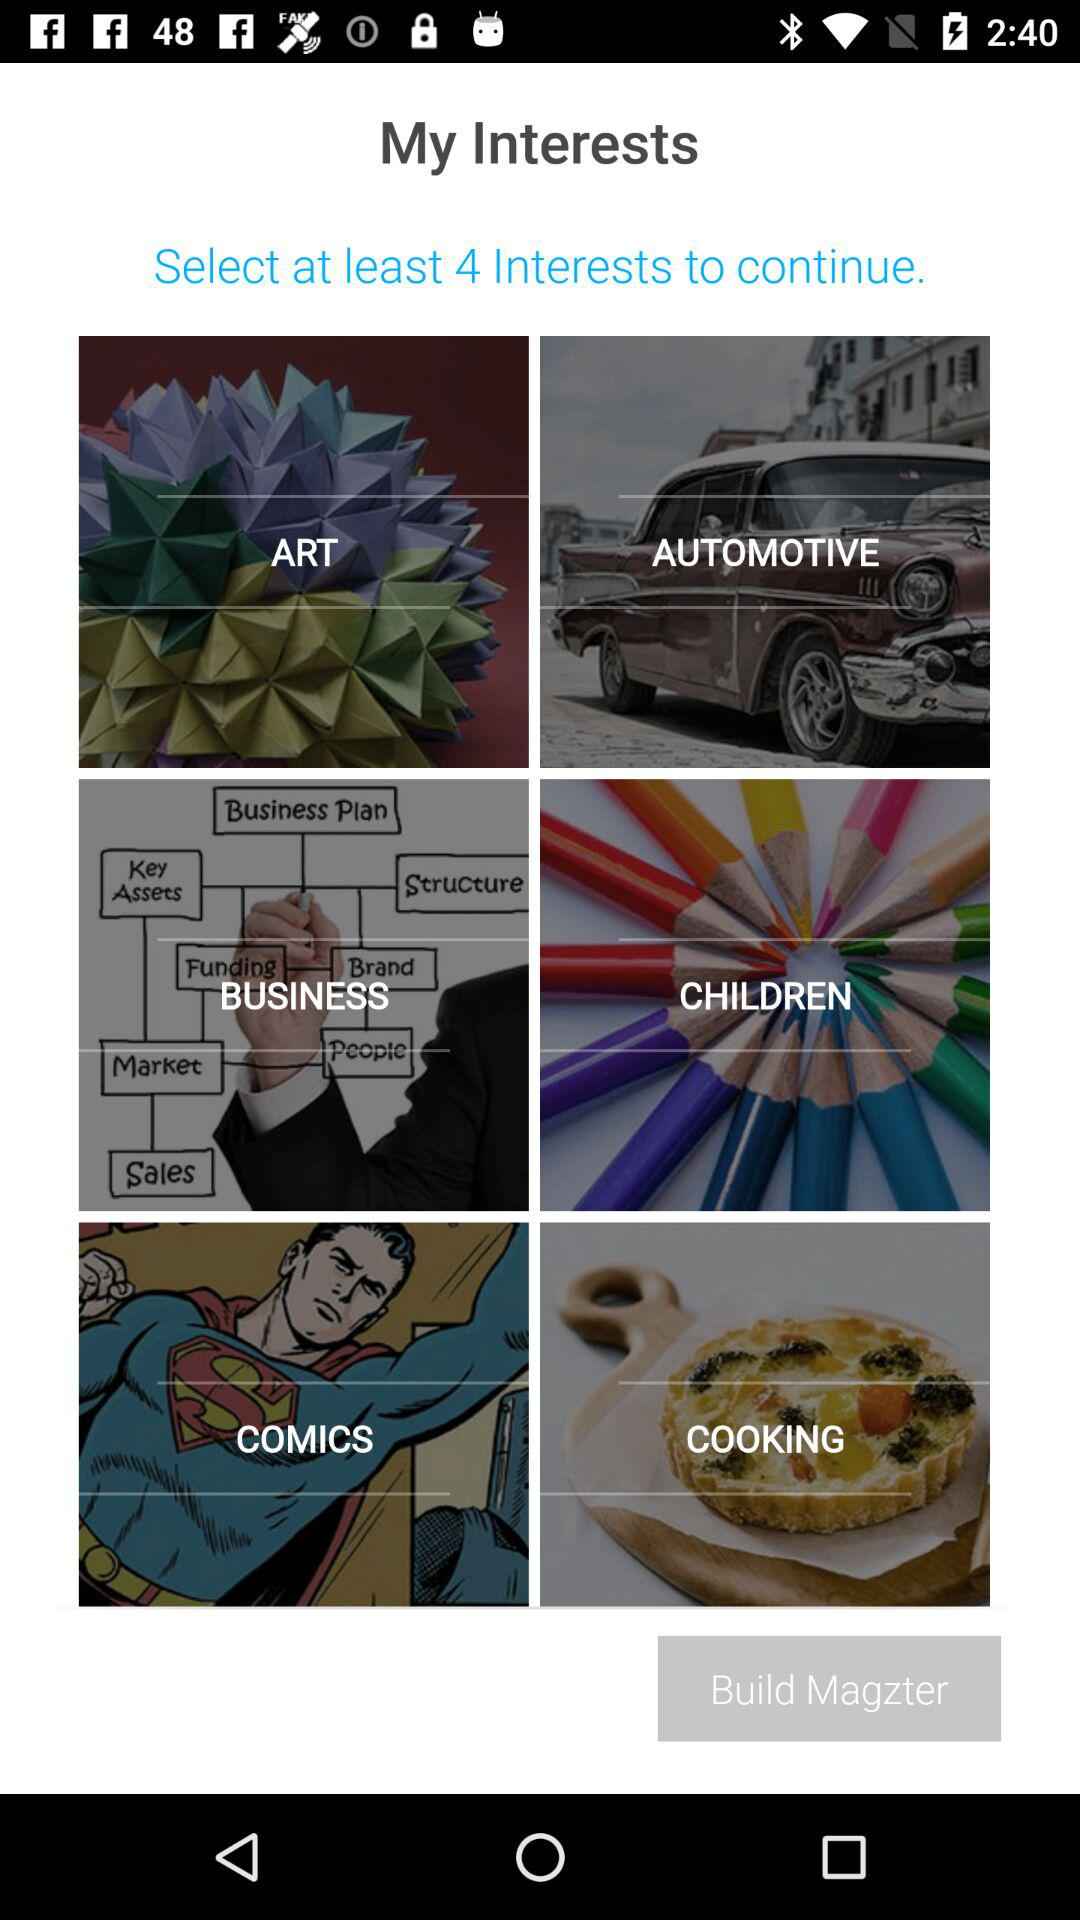What are the names of my interests? The names of my interests are: "Art", "Automotive", "Business", "Children", "Comics" and "Cooking". 